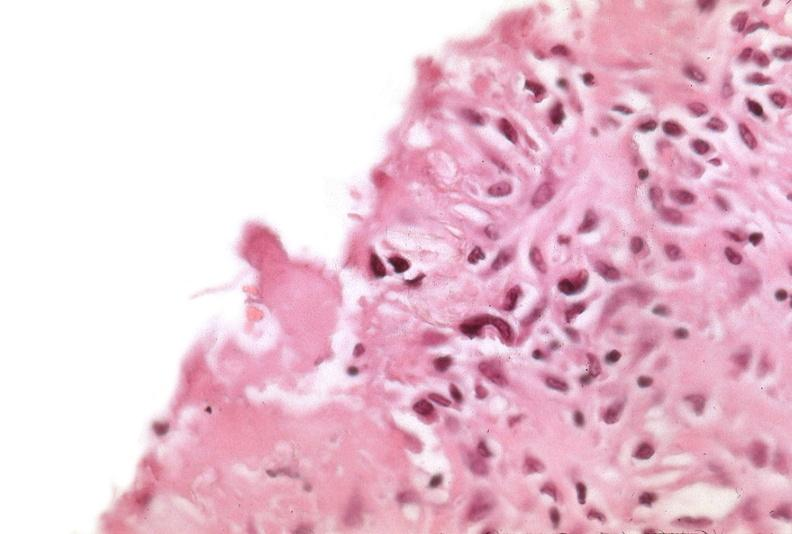was talc used to sclerose emphysematous lung, alpha-1 antitrypsin deficiency?
Answer the question using a single word or phrase. Yes 